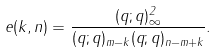<formula> <loc_0><loc_0><loc_500><loc_500>e ( k , n ) = \frac { ( q ; q ) _ { \infty } ^ { 2 } } { ( q ; q ) _ { m - k } ( q ; q ) _ { n - m + k } } .</formula> 